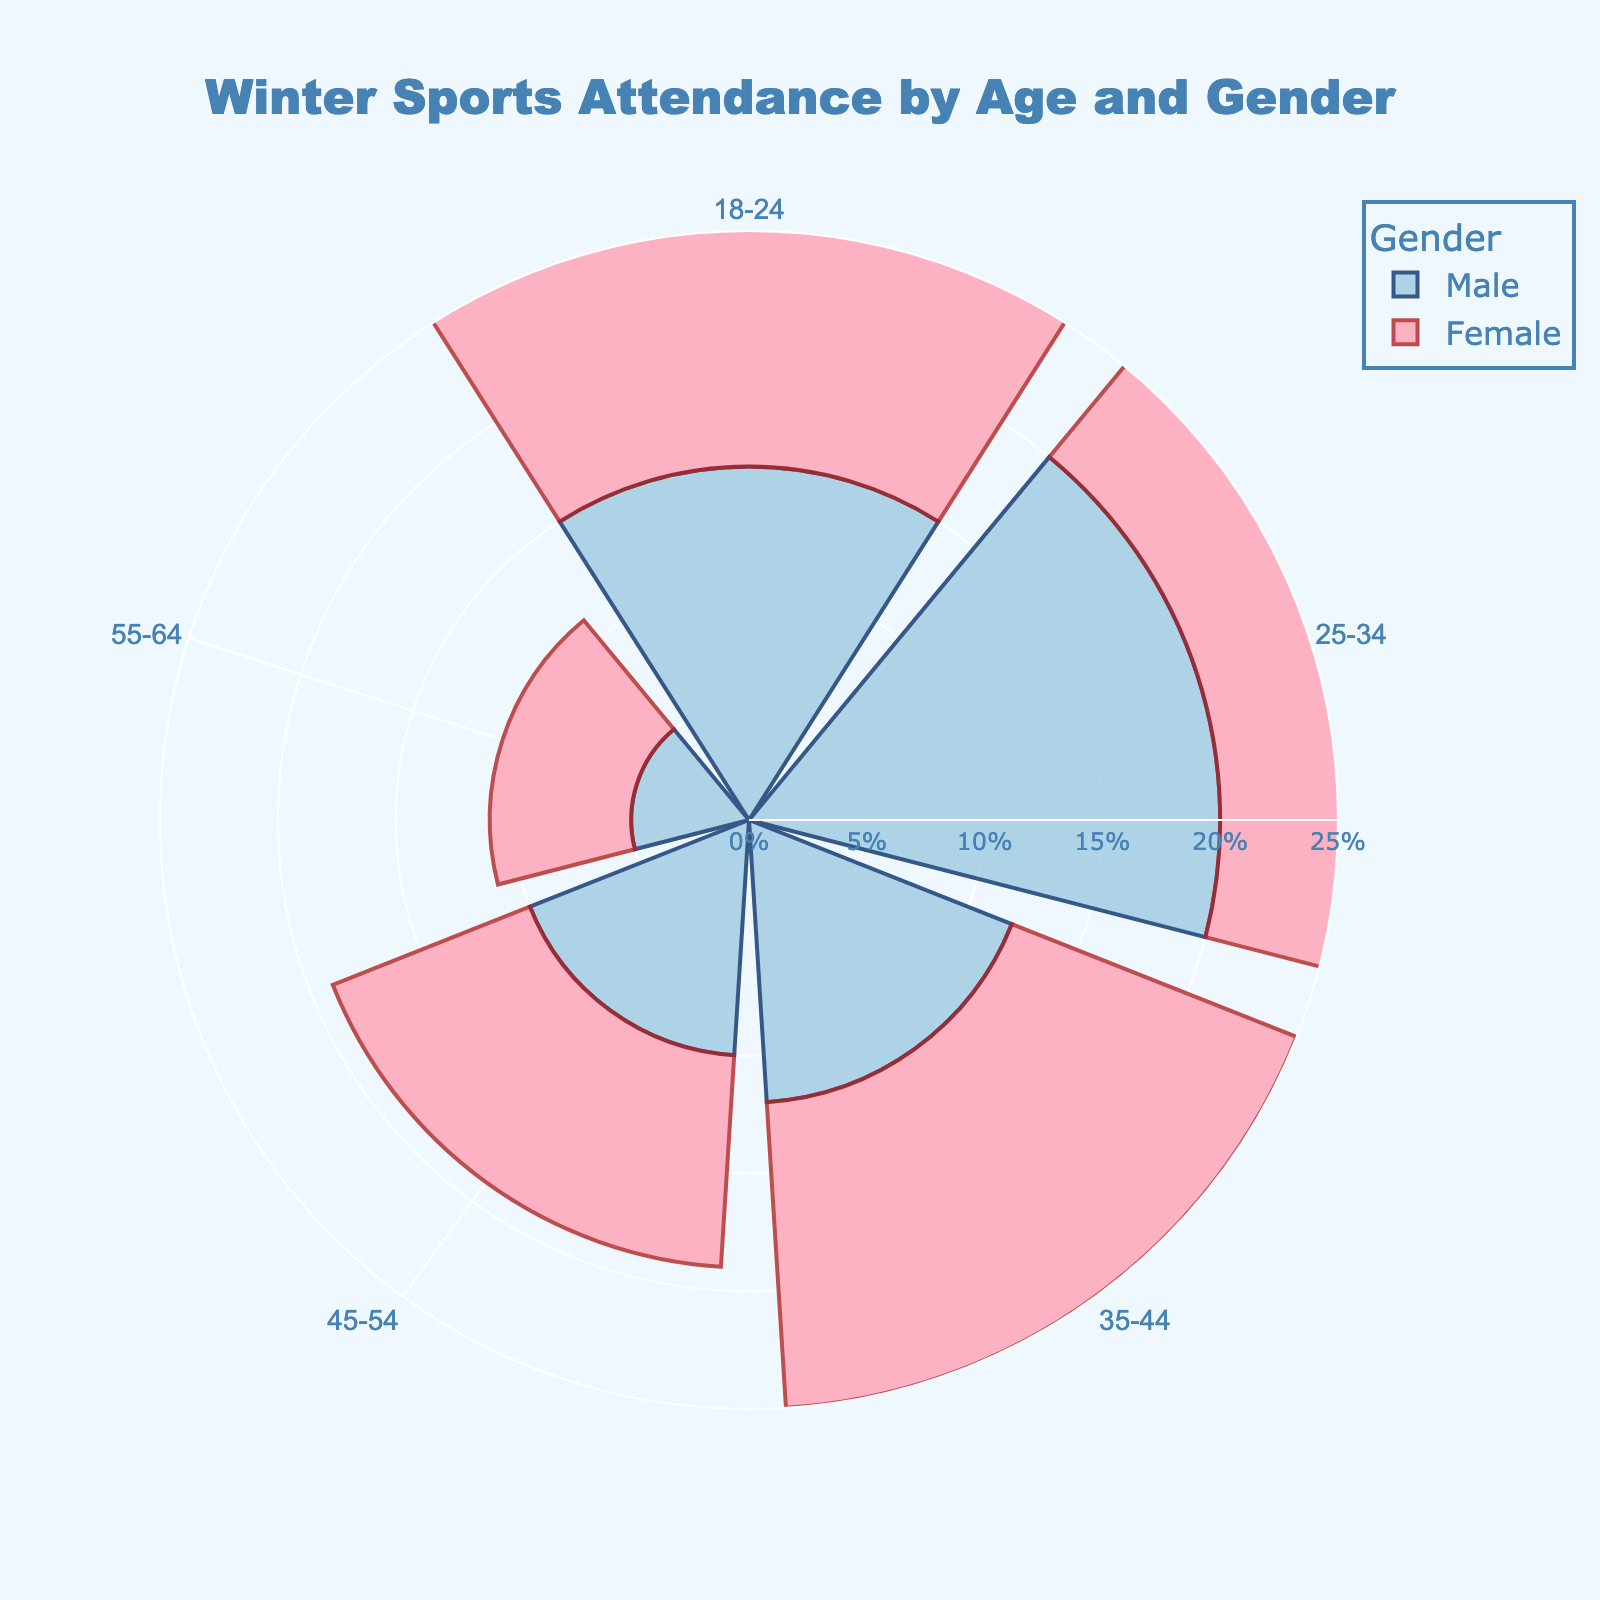What is the title of the figure? The title of the figure is usually presented at the top and in this case, it provides a summary of the data.
Answer: Winter Sports Attendance by Age and Gender How many age groups are represented in the chart? Each age group is usually displayed once on the angular axis of the rose chart. Count the number of distinct age groups shown.
Answer: 5 Which gender has the highest attendance percentage in the 25-34 age group? Look at the bars corresponding to the 25-34 age group and compare their heights for each gender.
Answer: Male What is the total attendance percentage for males across all age groups? Sum up the attendance percentages for males across all age groups: 15 (18-24) + 20 (25-34) + 12 (35-44) + 10 (45-54) + 5 (55-64).
Answer: 62% In which age group do females have the lowest attendance percentage? Compare the heights of the bars for females across all age groups and find the smallest bar.
Answer: 45-54 What is the difference in attendance percentage between males and females in the 35-44 age group? Subtract the attendance percentage for females from that of males in the 35-44 age group: 12 (male) - 13 (female).
Answer: -1% Which gender has a larger average attendance percentage across all age groups? Calculate the average attendance percentage for each gender by dividing the sum of attendance percentages by the number of age groups. Compare the averages.
Answer: Male How does the attendance percentage for the 45-54 age group compare to the one for the 18-24 age group? Compare the sum of attendance percentages for males and females in both age groups: (10 (male) + 9 (female)) for 45-54 and (15 (male) + 16 (female)) for 18-24.
Answer: 45-54 is lower In which age group is the difference between male and female attendance percentages the greatest? Calculate the absolute differences in attendance percentages for each age group and identify the group with the biggest difference.
Answer: 25-34 What is the combined attendance percentage for females aged 35-44 and 55-64? Sum the attendance percentages for females in the 35-44 and 55-64 age groups: 13 (35-44) + 6 (55-64).
Answer: 19% 